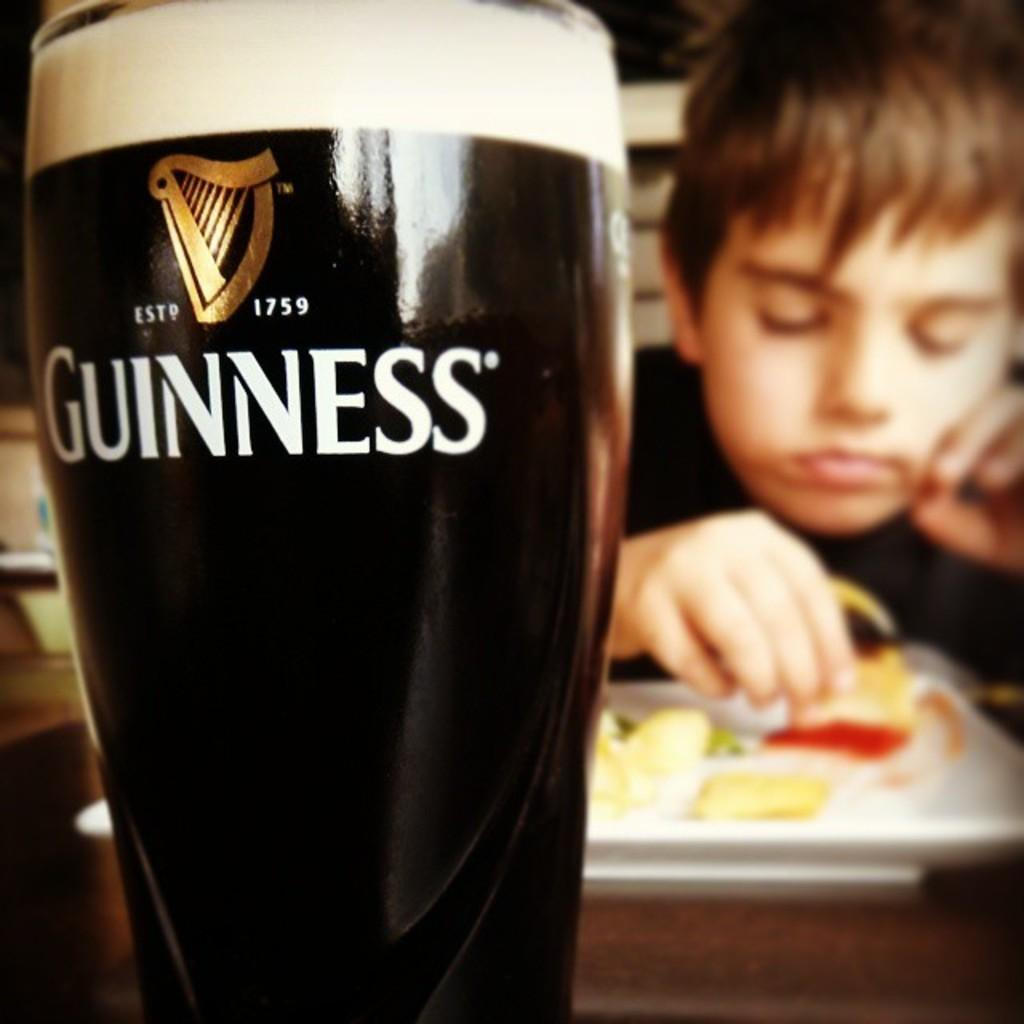What object is located on the left side of the image? There is a glass on the left side of the image. Where is the boy positioned in the image? The boy is in front of a food plate in the image. What is on the right side of the image? There is a food plate on the right side of the image. Reasoning: Let's think step by step by following the provided facts step by step to create the conversation. We start by identifying the main objects in the image, which are the glass and the food plate. Then, we describe their locations in the image, with the glass on the left and the food plate on the right. Finally, we mention the presence of the boy and his position in relation to the food plate. Absurd Question/Answer: What type of nation is represented by the chickens in the image? There are no chickens present in the image, so it is not possible to determine the representation of any nation. 